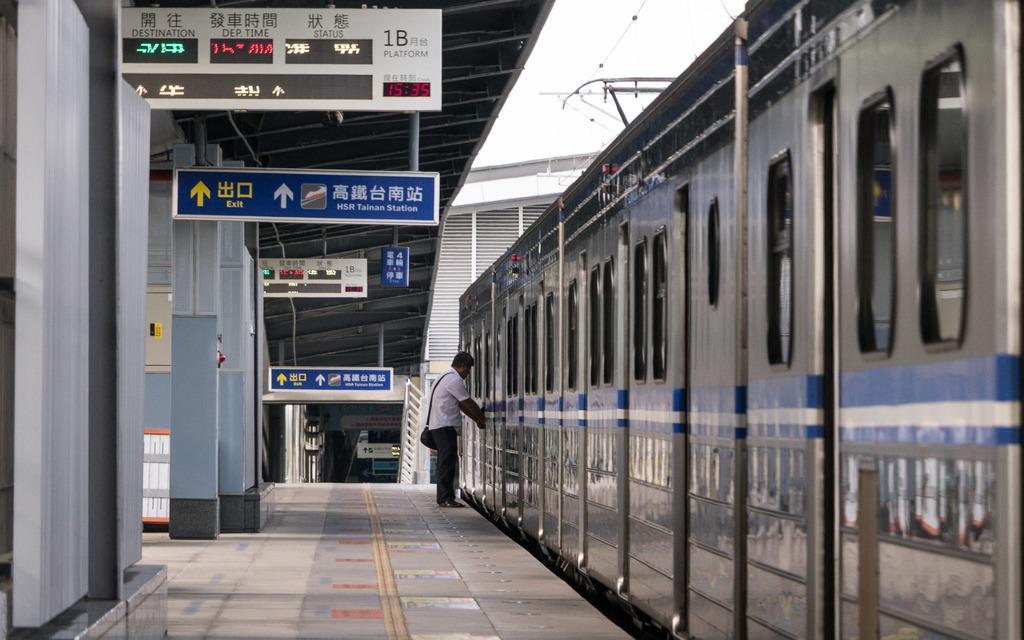Can you describe this image briefly? This picture describe about a silver color train parked on the railway station. In front we can see a man wearing white color shirt, opening the train door. On the left side we can see handing naming board and clock. Above we can see the shed and some electric cables. 